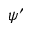<formula> <loc_0><loc_0><loc_500><loc_500>\psi ^ { \prime }</formula> 